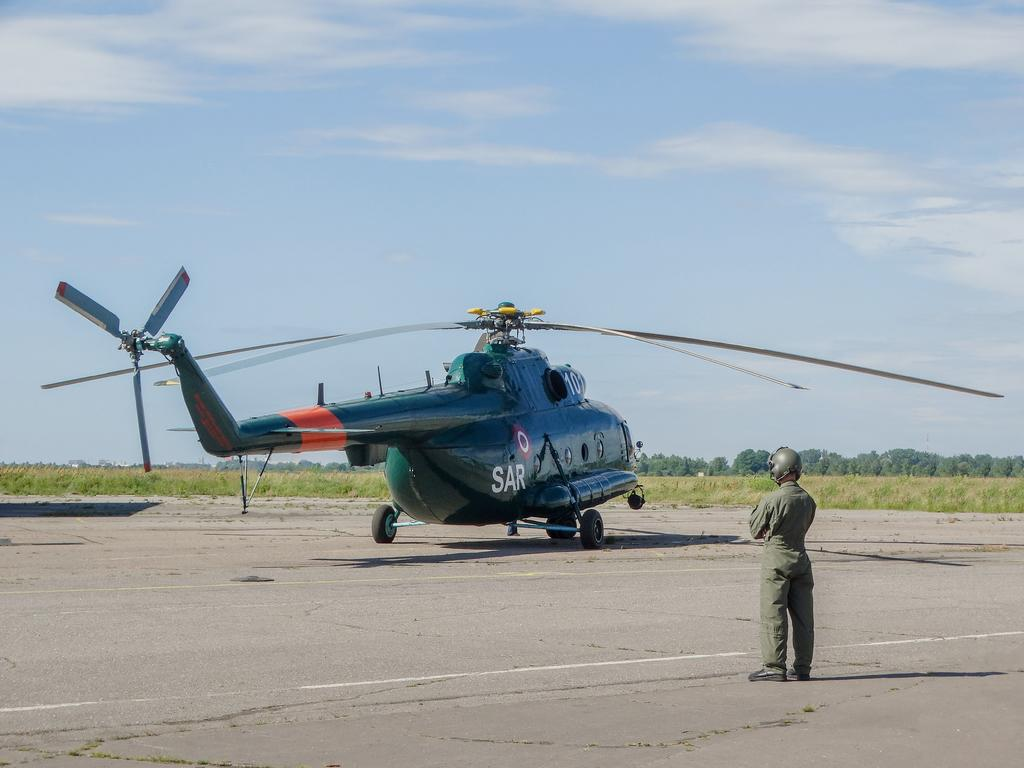What is the main subject of the picture? The main subject of the picture is a helicopter. Can you describe the person in the picture? There is a person on the ground in the picture. What can be seen in the background of the picture? There are trees and the sky visible in the background of the picture. Can you see a rabbit in the picture? There is no rabbit present in the image. 